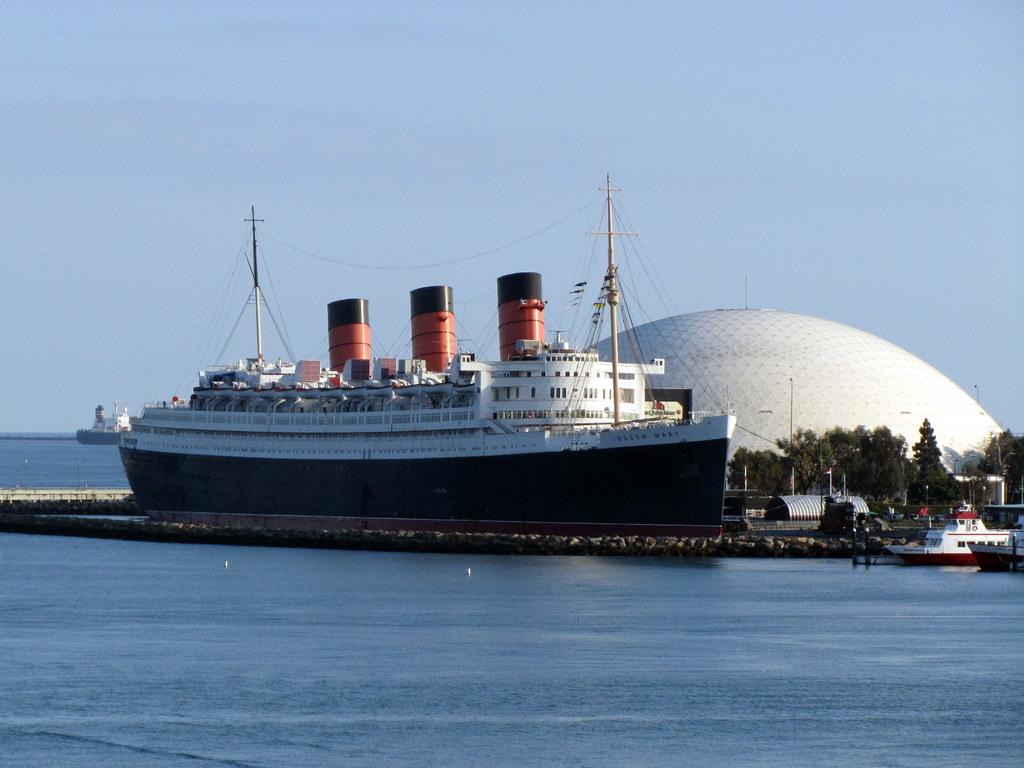What is the main subject of the image? The main subject of the image is ships. What can be seen in the background of the image? There are trees and a building in the background of the image. What is visible at the top of the image? The sky is visible at the top of the image. What type of insurance policy is being discussed by the bats flying in the image? There are no bats present in the image, and therefore no discussion about insurance policies can be observed. 